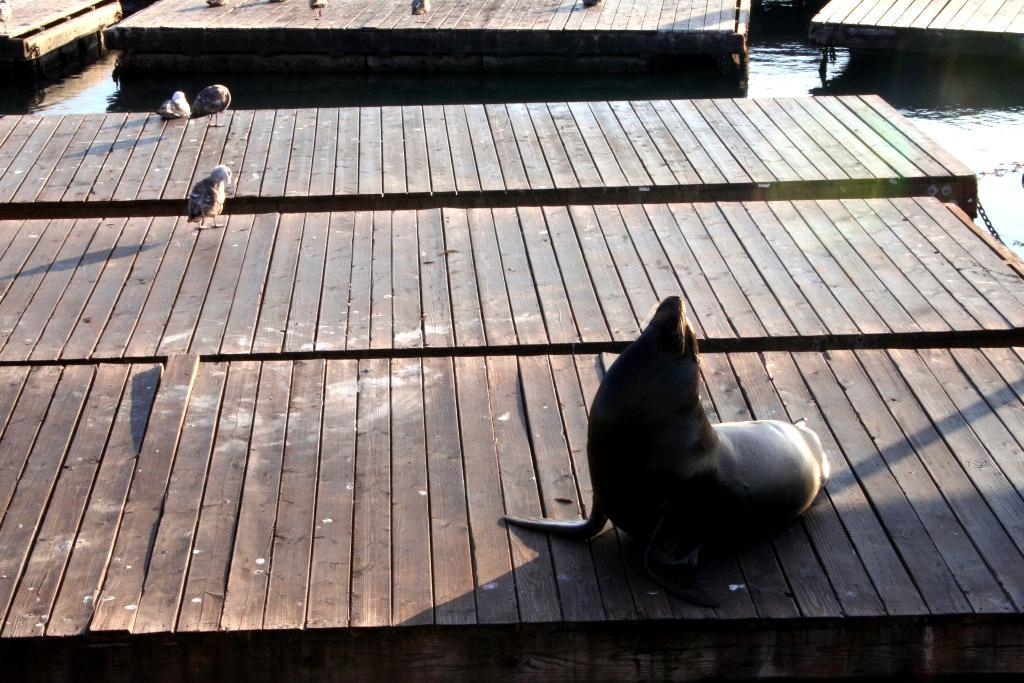What type of animal can be seen in the image? There is a seal in the image. What other animals are present in the image? There are birds in the image. What is the surface that the animals are on? The wooden surface is in the image, and it is on the water. What can be seen to the right in the image? There is a chain visible to the right in the image. What type of tin can be seen floating in space in the image? There is no tin or space present in the image; it features a seal, birds, a wooden surface, and a chain on water. 